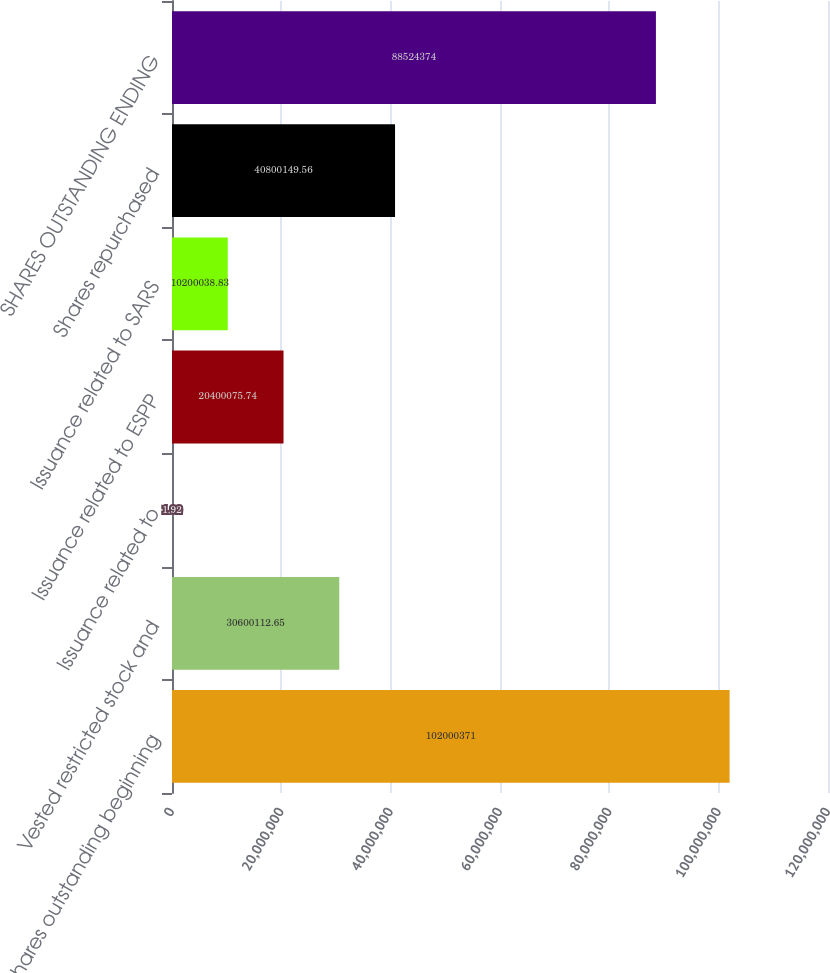Convert chart. <chart><loc_0><loc_0><loc_500><loc_500><bar_chart><fcel>Shares outstanding beginning<fcel>Vested restricted stock and<fcel>Issuance related to<fcel>Issuance related to ESPP<fcel>Issuance related to SARS<fcel>Shares repurchased<fcel>SHARES OUTSTANDING ENDING<nl><fcel>1.02e+08<fcel>3.06001e+07<fcel>1.92<fcel>2.04001e+07<fcel>1.02e+07<fcel>4.08001e+07<fcel>8.85244e+07<nl></chart> 